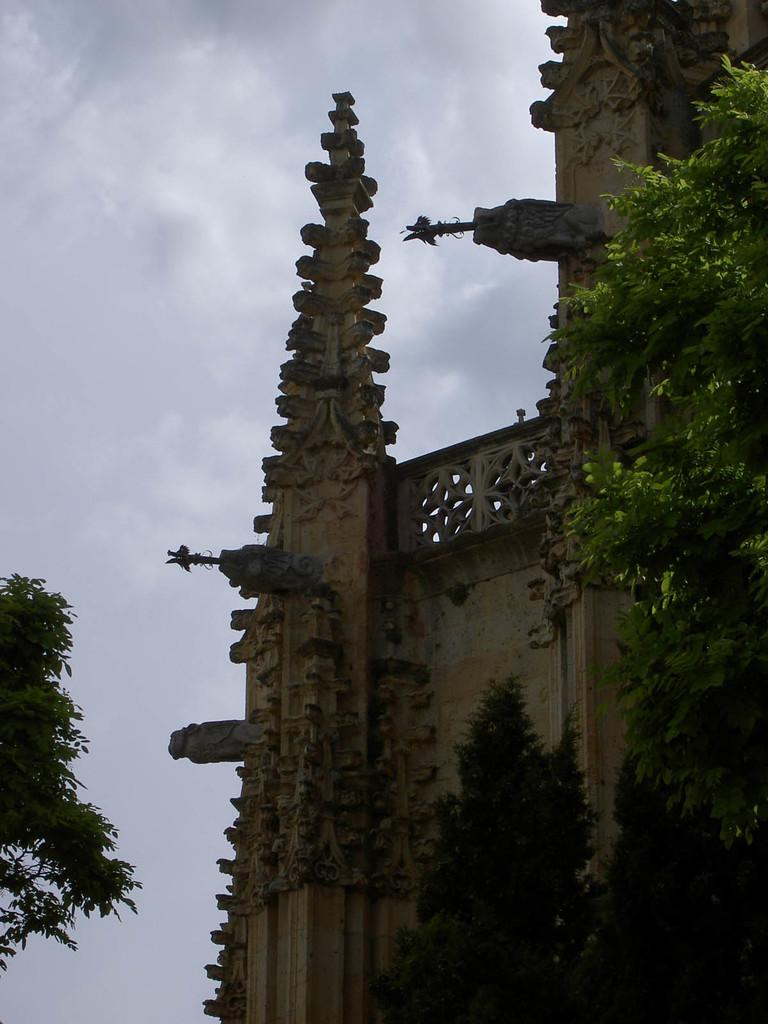What type of structure is visible in the image? There is a building in the image. What other natural elements can be seen in the image? There are trees in the image. How would you describe the color of the sky in the image? The sky is blue and white in color. What type of suit is the ground wearing in the image? There is no ground or suit present in the image; it features a building and trees. 